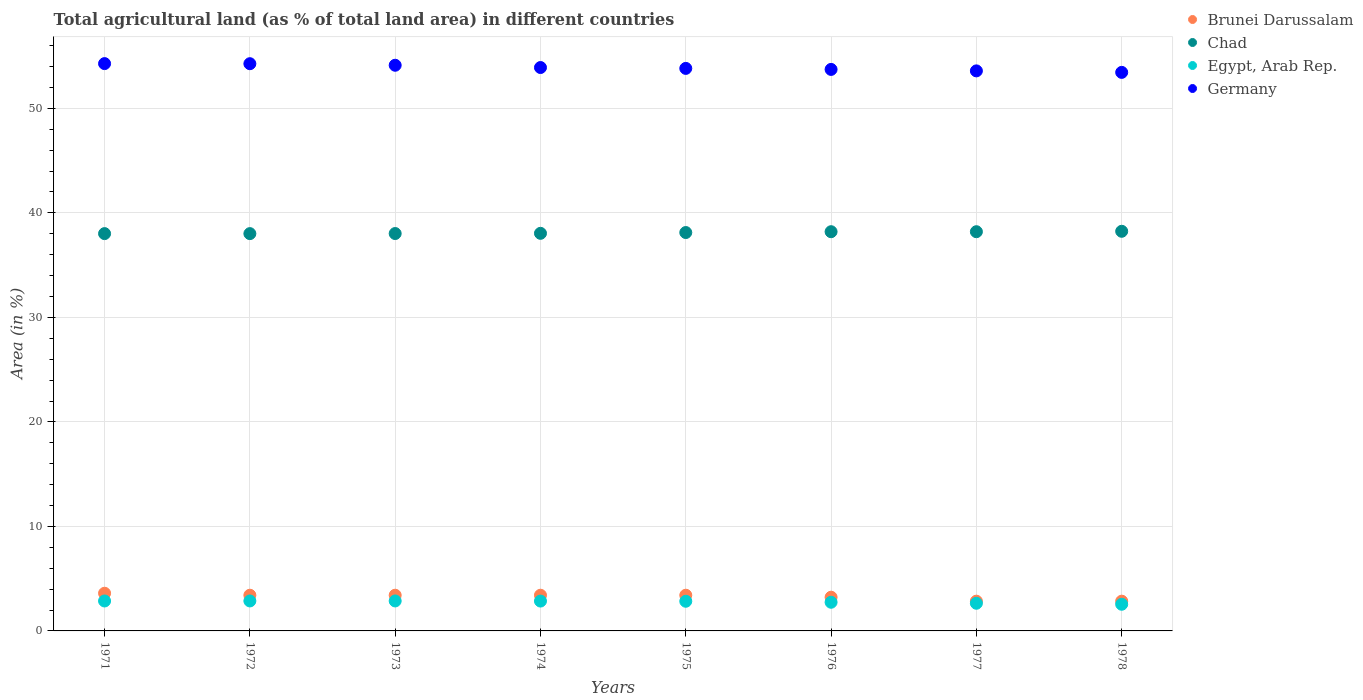What is the percentage of agricultural land in Chad in 1975?
Your answer should be very brief. 38.12. Across all years, what is the maximum percentage of agricultural land in Chad?
Offer a terse response. 38.24. Across all years, what is the minimum percentage of agricultural land in Brunei Darussalam?
Your response must be concise. 2.85. In which year was the percentage of agricultural land in Egypt, Arab Rep. minimum?
Your answer should be very brief. 1978. What is the total percentage of agricultural land in Germany in the graph?
Your response must be concise. 431.18. What is the difference between the percentage of agricultural land in Chad in 1975 and that in 1977?
Provide a succinct answer. -0.08. What is the difference between the percentage of agricultural land in Egypt, Arab Rep. in 1973 and the percentage of agricultural land in Chad in 1974?
Provide a short and direct response. -35.18. What is the average percentage of agricultural land in Egypt, Arab Rep. per year?
Offer a terse response. 2.78. In the year 1978, what is the difference between the percentage of agricultural land in Chad and percentage of agricultural land in Brunei Darussalam?
Offer a very short reply. 35.39. In how many years, is the percentage of agricultural land in Germany greater than 38 %?
Your answer should be very brief. 8. What is the ratio of the percentage of agricultural land in Chad in 1973 to that in 1974?
Your answer should be very brief. 1. Is the difference between the percentage of agricultural land in Chad in 1972 and 1973 greater than the difference between the percentage of agricultural land in Brunei Darussalam in 1972 and 1973?
Your response must be concise. No. What is the difference between the highest and the second highest percentage of agricultural land in Brunei Darussalam?
Your response must be concise. 0.19. What is the difference between the highest and the lowest percentage of agricultural land in Chad?
Make the answer very short. 0.22. In how many years, is the percentage of agricultural land in Germany greater than the average percentage of agricultural land in Germany taken over all years?
Make the answer very short. 4. How many dotlines are there?
Your answer should be very brief. 4. How many years are there in the graph?
Provide a short and direct response. 8. What is the difference between two consecutive major ticks on the Y-axis?
Ensure brevity in your answer.  10. Does the graph contain grids?
Provide a short and direct response. Yes. How many legend labels are there?
Give a very brief answer. 4. How are the legend labels stacked?
Provide a short and direct response. Vertical. What is the title of the graph?
Your answer should be compact. Total agricultural land (as % of total land area) in different countries. What is the label or title of the X-axis?
Keep it short and to the point. Years. What is the label or title of the Y-axis?
Give a very brief answer. Area (in %). What is the Area (in %) of Brunei Darussalam in 1971?
Make the answer very short. 3.61. What is the Area (in %) in Chad in 1971?
Make the answer very short. 38.02. What is the Area (in %) in Egypt, Arab Rep. in 1971?
Your answer should be compact. 2.87. What is the Area (in %) of Germany in 1971?
Your answer should be very brief. 54.28. What is the Area (in %) of Brunei Darussalam in 1972?
Your response must be concise. 3.42. What is the Area (in %) in Chad in 1972?
Make the answer very short. 38.02. What is the Area (in %) in Egypt, Arab Rep. in 1972?
Your answer should be very brief. 2.87. What is the Area (in %) of Germany in 1972?
Offer a terse response. 54.27. What is the Area (in %) of Brunei Darussalam in 1973?
Your answer should be compact. 3.42. What is the Area (in %) of Chad in 1973?
Your answer should be very brief. 38.02. What is the Area (in %) in Egypt, Arab Rep. in 1973?
Give a very brief answer. 2.87. What is the Area (in %) of Germany in 1973?
Your response must be concise. 54.13. What is the Area (in %) of Brunei Darussalam in 1974?
Your answer should be very brief. 3.42. What is the Area (in %) in Chad in 1974?
Your answer should be compact. 38.04. What is the Area (in %) of Egypt, Arab Rep. in 1974?
Your answer should be very brief. 2.86. What is the Area (in %) of Germany in 1974?
Offer a terse response. 53.91. What is the Area (in %) in Brunei Darussalam in 1975?
Provide a short and direct response. 3.42. What is the Area (in %) in Chad in 1975?
Keep it short and to the point. 38.12. What is the Area (in %) in Egypt, Arab Rep. in 1975?
Offer a terse response. 2.84. What is the Area (in %) in Germany in 1975?
Make the answer very short. 53.83. What is the Area (in %) in Brunei Darussalam in 1976?
Your answer should be very brief. 3.23. What is the Area (in %) in Chad in 1976?
Offer a terse response. 38.2. What is the Area (in %) in Egypt, Arab Rep. in 1976?
Provide a succinct answer. 2.74. What is the Area (in %) in Germany in 1976?
Your answer should be compact. 53.73. What is the Area (in %) in Brunei Darussalam in 1977?
Ensure brevity in your answer.  2.85. What is the Area (in %) in Chad in 1977?
Your response must be concise. 38.2. What is the Area (in %) in Egypt, Arab Rep. in 1977?
Offer a terse response. 2.65. What is the Area (in %) of Germany in 1977?
Your answer should be compact. 53.59. What is the Area (in %) of Brunei Darussalam in 1978?
Your answer should be compact. 2.85. What is the Area (in %) in Chad in 1978?
Ensure brevity in your answer.  38.24. What is the Area (in %) in Egypt, Arab Rep. in 1978?
Provide a short and direct response. 2.55. What is the Area (in %) in Germany in 1978?
Provide a short and direct response. 53.44. Across all years, what is the maximum Area (in %) of Brunei Darussalam?
Your answer should be compact. 3.61. Across all years, what is the maximum Area (in %) of Chad?
Offer a very short reply. 38.24. Across all years, what is the maximum Area (in %) of Egypt, Arab Rep.?
Provide a succinct answer. 2.87. Across all years, what is the maximum Area (in %) in Germany?
Offer a terse response. 54.28. Across all years, what is the minimum Area (in %) of Brunei Darussalam?
Offer a very short reply. 2.85. Across all years, what is the minimum Area (in %) in Chad?
Your answer should be compact. 38.02. Across all years, what is the minimum Area (in %) of Egypt, Arab Rep.?
Give a very brief answer. 2.55. Across all years, what is the minimum Area (in %) of Germany?
Offer a terse response. 53.44. What is the total Area (in %) in Brunei Darussalam in the graph?
Your response must be concise. 26.19. What is the total Area (in %) of Chad in the graph?
Ensure brevity in your answer.  304.86. What is the total Area (in %) of Egypt, Arab Rep. in the graph?
Your answer should be very brief. 22.24. What is the total Area (in %) in Germany in the graph?
Make the answer very short. 431.18. What is the difference between the Area (in %) of Brunei Darussalam in 1971 and that in 1972?
Your answer should be very brief. 0.19. What is the difference between the Area (in %) in Chad in 1971 and that in 1972?
Provide a succinct answer. 0. What is the difference between the Area (in %) in Egypt, Arab Rep. in 1971 and that in 1972?
Keep it short and to the point. -0. What is the difference between the Area (in %) of Germany in 1971 and that in 1972?
Offer a very short reply. 0.01. What is the difference between the Area (in %) in Brunei Darussalam in 1971 and that in 1973?
Offer a very short reply. 0.19. What is the difference between the Area (in %) of Chad in 1971 and that in 1973?
Ensure brevity in your answer.  -0.01. What is the difference between the Area (in %) of Egypt, Arab Rep. in 1971 and that in 1973?
Your answer should be compact. -0. What is the difference between the Area (in %) of Germany in 1971 and that in 1973?
Offer a very short reply. 0.16. What is the difference between the Area (in %) of Brunei Darussalam in 1971 and that in 1974?
Your response must be concise. 0.19. What is the difference between the Area (in %) in Chad in 1971 and that in 1974?
Offer a terse response. -0.03. What is the difference between the Area (in %) in Egypt, Arab Rep. in 1971 and that in 1974?
Your answer should be very brief. 0.01. What is the difference between the Area (in %) in Germany in 1971 and that in 1974?
Keep it short and to the point. 0.38. What is the difference between the Area (in %) of Brunei Darussalam in 1971 and that in 1975?
Offer a terse response. 0.19. What is the difference between the Area (in %) in Chad in 1971 and that in 1975?
Your answer should be very brief. -0.1. What is the difference between the Area (in %) in Egypt, Arab Rep. in 1971 and that in 1975?
Ensure brevity in your answer.  0.03. What is the difference between the Area (in %) in Germany in 1971 and that in 1975?
Ensure brevity in your answer.  0.46. What is the difference between the Area (in %) of Brunei Darussalam in 1971 and that in 1976?
Give a very brief answer. 0.38. What is the difference between the Area (in %) in Chad in 1971 and that in 1976?
Provide a short and direct response. -0.18. What is the difference between the Area (in %) of Egypt, Arab Rep. in 1971 and that in 1976?
Keep it short and to the point. 0.12. What is the difference between the Area (in %) of Germany in 1971 and that in 1976?
Offer a terse response. 0.56. What is the difference between the Area (in %) in Brunei Darussalam in 1971 and that in 1977?
Make the answer very short. 0.76. What is the difference between the Area (in %) of Chad in 1971 and that in 1977?
Ensure brevity in your answer.  -0.18. What is the difference between the Area (in %) in Egypt, Arab Rep. in 1971 and that in 1977?
Your response must be concise. 0.22. What is the difference between the Area (in %) of Germany in 1971 and that in 1977?
Make the answer very short. 0.7. What is the difference between the Area (in %) in Brunei Darussalam in 1971 and that in 1978?
Your answer should be very brief. 0.76. What is the difference between the Area (in %) of Chad in 1971 and that in 1978?
Your answer should be very brief. -0.22. What is the difference between the Area (in %) of Egypt, Arab Rep. in 1971 and that in 1978?
Keep it short and to the point. 0.31. What is the difference between the Area (in %) in Germany in 1971 and that in 1978?
Offer a terse response. 0.84. What is the difference between the Area (in %) in Brunei Darussalam in 1972 and that in 1973?
Provide a succinct answer. 0. What is the difference between the Area (in %) in Chad in 1972 and that in 1973?
Offer a terse response. -0.01. What is the difference between the Area (in %) of Egypt, Arab Rep. in 1972 and that in 1973?
Give a very brief answer. 0. What is the difference between the Area (in %) in Germany in 1972 and that in 1973?
Provide a short and direct response. 0.15. What is the difference between the Area (in %) of Chad in 1972 and that in 1974?
Offer a terse response. -0.03. What is the difference between the Area (in %) of Egypt, Arab Rep. in 1972 and that in 1974?
Provide a short and direct response. 0.01. What is the difference between the Area (in %) in Germany in 1972 and that in 1974?
Make the answer very short. 0.37. What is the difference between the Area (in %) of Brunei Darussalam in 1972 and that in 1975?
Your response must be concise. 0. What is the difference between the Area (in %) in Chad in 1972 and that in 1975?
Your answer should be very brief. -0.1. What is the difference between the Area (in %) in Egypt, Arab Rep. in 1972 and that in 1975?
Your answer should be compact. 0.03. What is the difference between the Area (in %) of Germany in 1972 and that in 1975?
Provide a succinct answer. 0.45. What is the difference between the Area (in %) of Brunei Darussalam in 1972 and that in 1976?
Your answer should be compact. 0.19. What is the difference between the Area (in %) of Chad in 1972 and that in 1976?
Make the answer very short. -0.18. What is the difference between the Area (in %) in Egypt, Arab Rep. in 1972 and that in 1976?
Your answer should be very brief. 0.13. What is the difference between the Area (in %) of Germany in 1972 and that in 1976?
Offer a terse response. 0.55. What is the difference between the Area (in %) in Brunei Darussalam in 1972 and that in 1977?
Make the answer very short. 0.57. What is the difference between the Area (in %) of Chad in 1972 and that in 1977?
Provide a short and direct response. -0.18. What is the difference between the Area (in %) in Egypt, Arab Rep. in 1972 and that in 1977?
Offer a very short reply. 0.22. What is the difference between the Area (in %) of Germany in 1972 and that in 1977?
Your answer should be compact. 0.69. What is the difference between the Area (in %) of Brunei Darussalam in 1972 and that in 1978?
Provide a short and direct response. 0.57. What is the difference between the Area (in %) in Chad in 1972 and that in 1978?
Give a very brief answer. -0.22. What is the difference between the Area (in %) in Egypt, Arab Rep. in 1972 and that in 1978?
Provide a short and direct response. 0.32. What is the difference between the Area (in %) of Germany in 1972 and that in 1978?
Offer a terse response. 0.83. What is the difference between the Area (in %) in Brunei Darussalam in 1973 and that in 1974?
Make the answer very short. 0. What is the difference between the Area (in %) in Chad in 1973 and that in 1974?
Your response must be concise. -0.02. What is the difference between the Area (in %) in Egypt, Arab Rep. in 1973 and that in 1974?
Ensure brevity in your answer.  0.01. What is the difference between the Area (in %) in Germany in 1973 and that in 1974?
Offer a very short reply. 0.22. What is the difference between the Area (in %) in Chad in 1973 and that in 1975?
Your answer should be very brief. -0.1. What is the difference between the Area (in %) of Egypt, Arab Rep. in 1973 and that in 1975?
Your answer should be compact. 0.03. What is the difference between the Area (in %) of Germany in 1973 and that in 1975?
Ensure brevity in your answer.  0.3. What is the difference between the Area (in %) of Brunei Darussalam in 1973 and that in 1976?
Keep it short and to the point. 0.19. What is the difference between the Area (in %) of Chad in 1973 and that in 1976?
Give a very brief answer. -0.17. What is the difference between the Area (in %) of Egypt, Arab Rep. in 1973 and that in 1976?
Offer a very short reply. 0.13. What is the difference between the Area (in %) of Germany in 1973 and that in 1976?
Keep it short and to the point. 0.4. What is the difference between the Area (in %) in Brunei Darussalam in 1973 and that in 1977?
Your answer should be compact. 0.57. What is the difference between the Area (in %) in Chad in 1973 and that in 1977?
Offer a very short reply. -0.17. What is the difference between the Area (in %) of Egypt, Arab Rep. in 1973 and that in 1977?
Offer a very short reply. 0.22. What is the difference between the Area (in %) of Germany in 1973 and that in 1977?
Give a very brief answer. 0.54. What is the difference between the Area (in %) of Brunei Darussalam in 1973 and that in 1978?
Your answer should be compact. 0.57. What is the difference between the Area (in %) in Chad in 1973 and that in 1978?
Offer a very short reply. -0.21. What is the difference between the Area (in %) of Egypt, Arab Rep. in 1973 and that in 1978?
Offer a terse response. 0.32. What is the difference between the Area (in %) in Germany in 1973 and that in 1978?
Provide a succinct answer. 0.68. What is the difference between the Area (in %) of Chad in 1974 and that in 1975?
Ensure brevity in your answer.  -0.08. What is the difference between the Area (in %) in Egypt, Arab Rep. in 1974 and that in 1975?
Your answer should be very brief. 0.02. What is the difference between the Area (in %) of Germany in 1974 and that in 1975?
Your answer should be very brief. 0.08. What is the difference between the Area (in %) in Brunei Darussalam in 1974 and that in 1976?
Your answer should be very brief. 0.19. What is the difference between the Area (in %) in Chad in 1974 and that in 1976?
Ensure brevity in your answer.  -0.15. What is the difference between the Area (in %) in Egypt, Arab Rep. in 1974 and that in 1976?
Keep it short and to the point. 0.11. What is the difference between the Area (in %) in Germany in 1974 and that in 1976?
Provide a short and direct response. 0.18. What is the difference between the Area (in %) of Brunei Darussalam in 1974 and that in 1977?
Your answer should be compact. 0.57. What is the difference between the Area (in %) of Chad in 1974 and that in 1977?
Keep it short and to the point. -0.15. What is the difference between the Area (in %) of Egypt, Arab Rep. in 1974 and that in 1977?
Offer a very short reply. 0.21. What is the difference between the Area (in %) of Germany in 1974 and that in 1977?
Offer a terse response. 0.32. What is the difference between the Area (in %) of Brunei Darussalam in 1974 and that in 1978?
Make the answer very short. 0.57. What is the difference between the Area (in %) of Chad in 1974 and that in 1978?
Provide a succinct answer. -0.19. What is the difference between the Area (in %) of Egypt, Arab Rep. in 1974 and that in 1978?
Offer a terse response. 0.3. What is the difference between the Area (in %) of Germany in 1974 and that in 1978?
Provide a short and direct response. 0.46. What is the difference between the Area (in %) of Brunei Darussalam in 1975 and that in 1976?
Make the answer very short. 0.19. What is the difference between the Area (in %) of Chad in 1975 and that in 1976?
Offer a terse response. -0.08. What is the difference between the Area (in %) of Egypt, Arab Rep. in 1975 and that in 1976?
Keep it short and to the point. 0.1. What is the difference between the Area (in %) in Germany in 1975 and that in 1976?
Ensure brevity in your answer.  0.1. What is the difference between the Area (in %) of Brunei Darussalam in 1975 and that in 1977?
Offer a terse response. 0.57. What is the difference between the Area (in %) of Chad in 1975 and that in 1977?
Give a very brief answer. -0.08. What is the difference between the Area (in %) in Egypt, Arab Rep. in 1975 and that in 1977?
Your answer should be very brief. 0.19. What is the difference between the Area (in %) of Germany in 1975 and that in 1977?
Give a very brief answer. 0.24. What is the difference between the Area (in %) of Brunei Darussalam in 1975 and that in 1978?
Make the answer very short. 0.57. What is the difference between the Area (in %) of Chad in 1975 and that in 1978?
Your response must be concise. -0.12. What is the difference between the Area (in %) of Egypt, Arab Rep. in 1975 and that in 1978?
Provide a short and direct response. 0.29. What is the difference between the Area (in %) in Germany in 1975 and that in 1978?
Provide a short and direct response. 0.38. What is the difference between the Area (in %) of Brunei Darussalam in 1976 and that in 1977?
Offer a very short reply. 0.38. What is the difference between the Area (in %) in Chad in 1976 and that in 1977?
Ensure brevity in your answer.  0. What is the difference between the Area (in %) in Egypt, Arab Rep. in 1976 and that in 1977?
Your response must be concise. 0.1. What is the difference between the Area (in %) of Germany in 1976 and that in 1977?
Your answer should be compact. 0.14. What is the difference between the Area (in %) in Brunei Darussalam in 1976 and that in 1978?
Offer a terse response. 0.38. What is the difference between the Area (in %) of Chad in 1976 and that in 1978?
Provide a short and direct response. -0.04. What is the difference between the Area (in %) in Egypt, Arab Rep. in 1976 and that in 1978?
Provide a short and direct response. 0.19. What is the difference between the Area (in %) of Germany in 1976 and that in 1978?
Provide a succinct answer. 0.28. What is the difference between the Area (in %) of Chad in 1977 and that in 1978?
Provide a short and direct response. -0.04. What is the difference between the Area (in %) of Egypt, Arab Rep. in 1977 and that in 1978?
Your response must be concise. 0.1. What is the difference between the Area (in %) in Germany in 1977 and that in 1978?
Give a very brief answer. 0.14. What is the difference between the Area (in %) of Brunei Darussalam in 1971 and the Area (in %) of Chad in 1972?
Provide a short and direct response. -34.41. What is the difference between the Area (in %) in Brunei Darussalam in 1971 and the Area (in %) in Egypt, Arab Rep. in 1972?
Keep it short and to the point. 0.74. What is the difference between the Area (in %) in Brunei Darussalam in 1971 and the Area (in %) in Germany in 1972?
Give a very brief answer. -50.67. What is the difference between the Area (in %) of Chad in 1971 and the Area (in %) of Egypt, Arab Rep. in 1972?
Provide a short and direct response. 35.15. What is the difference between the Area (in %) in Chad in 1971 and the Area (in %) in Germany in 1972?
Give a very brief answer. -16.26. What is the difference between the Area (in %) of Egypt, Arab Rep. in 1971 and the Area (in %) of Germany in 1972?
Ensure brevity in your answer.  -51.41. What is the difference between the Area (in %) of Brunei Darussalam in 1971 and the Area (in %) of Chad in 1973?
Your answer should be compact. -34.42. What is the difference between the Area (in %) of Brunei Darussalam in 1971 and the Area (in %) of Egypt, Arab Rep. in 1973?
Ensure brevity in your answer.  0.74. What is the difference between the Area (in %) of Brunei Darussalam in 1971 and the Area (in %) of Germany in 1973?
Offer a very short reply. -50.52. What is the difference between the Area (in %) in Chad in 1971 and the Area (in %) in Egypt, Arab Rep. in 1973?
Offer a very short reply. 35.15. What is the difference between the Area (in %) in Chad in 1971 and the Area (in %) in Germany in 1973?
Give a very brief answer. -16.11. What is the difference between the Area (in %) of Egypt, Arab Rep. in 1971 and the Area (in %) of Germany in 1973?
Offer a very short reply. -51.26. What is the difference between the Area (in %) in Brunei Darussalam in 1971 and the Area (in %) in Chad in 1974?
Your answer should be compact. -34.44. What is the difference between the Area (in %) of Brunei Darussalam in 1971 and the Area (in %) of Egypt, Arab Rep. in 1974?
Make the answer very short. 0.75. What is the difference between the Area (in %) of Brunei Darussalam in 1971 and the Area (in %) of Germany in 1974?
Ensure brevity in your answer.  -50.3. What is the difference between the Area (in %) of Chad in 1971 and the Area (in %) of Egypt, Arab Rep. in 1974?
Ensure brevity in your answer.  35.16. What is the difference between the Area (in %) of Chad in 1971 and the Area (in %) of Germany in 1974?
Offer a terse response. -15.89. What is the difference between the Area (in %) in Egypt, Arab Rep. in 1971 and the Area (in %) in Germany in 1974?
Provide a short and direct response. -51.04. What is the difference between the Area (in %) in Brunei Darussalam in 1971 and the Area (in %) in Chad in 1975?
Provide a succinct answer. -34.51. What is the difference between the Area (in %) of Brunei Darussalam in 1971 and the Area (in %) of Egypt, Arab Rep. in 1975?
Give a very brief answer. 0.77. What is the difference between the Area (in %) in Brunei Darussalam in 1971 and the Area (in %) in Germany in 1975?
Offer a very short reply. -50.22. What is the difference between the Area (in %) of Chad in 1971 and the Area (in %) of Egypt, Arab Rep. in 1975?
Keep it short and to the point. 35.18. What is the difference between the Area (in %) of Chad in 1971 and the Area (in %) of Germany in 1975?
Keep it short and to the point. -15.81. What is the difference between the Area (in %) of Egypt, Arab Rep. in 1971 and the Area (in %) of Germany in 1975?
Offer a terse response. -50.96. What is the difference between the Area (in %) of Brunei Darussalam in 1971 and the Area (in %) of Chad in 1976?
Make the answer very short. -34.59. What is the difference between the Area (in %) of Brunei Darussalam in 1971 and the Area (in %) of Egypt, Arab Rep. in 1976?
Give a very brief answer. 0.86. What is the difference between the Area (in %) of Brunei Darussalam in 1971 and the Area (in %) of Germany in 1976?
Your answer should be very brief. -50.12. What is the difference between the Area (in %) of Chad in 1971 and the Area (in %) of Egypt, Arab Rep. in 1976?
Your answer should be compact. 35.27. What is the difference between the Area (in %) in Chad in 1971 and the Area (in %) in Germany in 1976?
Ensure brevity in your answer.  -15.71. What is the difference between the Area (in %) in Egypt, Arab Rep. in 1971 and the Area (in %) in Germany in 1976?
Make the answer very short. -50.86. What is the difference between the Area (in %) of Brunei Darussalam in 1971 and the Area (in %) of Chad in 1977?
Ensure brevity in your answer.  -34.59. What is the difference between the Area (in %) of Brunei Darussalam in 1971 and the Area (in %) of Egypt, Arab Rep. in 1977?
Give a very brief answer. 0.96. What is the difference between the Area (in %) in Brunei Darussalam in 1971 and the Area (in %) in Germany in 1977?
Your answer should be compact. -49.98. What is the difference between the Area (in %) in Chad in 1971 and the Area (in %) in Egypt, Arab Rep. in 1977?
Keep it short and to the point. 35.37. What is the difference between the Area (in %) in Chad in 1971 and the Area (in %) in Germany in 1977?
Make the answer very short. -15.57. What is the difference between the Area (in %) of Egypt, Arab Rep. in 1971 and the Area (in %) of Germany in 1977?
Ensure brevity in your answer.  -50.72. What is the difference between the Area (in %) in Brunei Darussalam in 1971 and the Area (in %) in Chad in 1978?
Give a very brief answer. -34.63. What is the difference between the Area (in %) in Brunei Darussalam in 1971 and the Area (in %) in Egypt, Arab Rep. in 1978?
Provide a short and direct response. 1.05. What is the difference between the Area (in %) in Brunei Darussalam in 1971 and the Area (in %) in Germany in 1978?
Offer a terse response. -49.84. What is the difference between the Area (in %) in Chad in 1971 and the Area (in %) in Egypt, Arab Rep. in 1978?
Keep it short and to the point. 35.46. What is the difference between the Area (in %) in Chad in 1971 and the Area (in %) in Germany in 1978?
Your response must be concise. -15.43. What is the difference between the Area (in %) of Egypt, Arab Rep. in 1971 and the Area (in %) of Germany in 1978?
Provide a short and direct response. -50.58. What is the difference between the Area (in %) of Brunei Darussalam in 1972 and the Area (in %) of Chad in 1973?
Make the answer very short. -34.61. What is the difference between the Area (in %) of Brunei Darussalam in 1972 and the Area (in %) of Egypt, Arab Rep. in 1973?
Make the answer very short. 0.55. What is the difference between the Area (in %) in Brunei Darussalam in 1972 and the Area (in %) in Germany in 1973?
Keep it short and to the point. -50.71. What is the difference between the Area (in %) in Chad in 1972 and the Area (in %) in Egypt, Arab Rep. in 1973?
Provide a succinct answer. 35.15. What is the difference between the Area (in %) in Chad in 1972 and the Area (in %) in Germany in 1973?
Provide a succinct answer. -16.11. What is the difference between the Area (in %) in Egypt, Arab Rep. in 1972 and the Area (in %) in Germany in 1973?
Make the answer very short. -51.26. What is the difference between the Area (in %) of Brunei Darussalam in 1972 and the Area (in %) of Chad in 1974?
Ensure brevity in your answer.  -34.63. What is the difference between the Area (in %) in Brunei Darussalam in 1972 and the Area (in %) in Egypt, Arab Rep. in 1974?
Give a very brief answer. 0.56. What is the difference between the Area (in %) in Brunei Darussalam in 1972 and the Area (in %) in Germany in 1974?
Offer a very short reply. -50.49. What is the difference between the Area (in %) in Chad in 1972 and the Area (in %) in Egypt, Arab Rep. in 1974?
Offer a very short reply. 35.16. What is the difference between the Area (in %) in Chad in 1972 and the Area (in %) in Germany in 1974?
Your answer should be compact. -15.89. What is the difference between the Area (in %) in Egypt, Arab Rep. in 1972 and the Area (in %) in Germany in 1974?
Your response must be concise. -51.04. What is the difference between the Area (in %) of Brunei Darussalam in 1972 and the Area (in %) of Chad in 1975?
Make the answer very short. -34.7. What is the difference between the Area (in %) in Brunei Darussalam in 1972 and the Area (in %) in Egypt, Arab Rep. in 1975?
Ensure brevity in your answer.  0.58. What is the difference between the Area (in %) in Brunei Darussalam in 1972 and the Area (in %) in Germany in 1975?
Offer a very short reply. -50.41. What is the difference between the Area (in %) in Chad in 1972 and the Area (in %) in Egypt, Arab Rep. in 1975?
Give a very brief answer. 35.18. What is the difference between the Area (in %) in Chad in 1972 and the Area (in %) in Germany in 1975?
Your answer should be very brief. -15.81. What is the difference between the Area (in %) of Egypt, Arab Rep. in 1972 and the Area (in %) of Germany in 1975?
Keep it short and to the point. -50.96. What is the difference between the Area (in %) in Brunei Darussalam in 1972 and the Area (in %) in Chad in 1976?
Make the answer very short. -34.78. What is the difference between the Area (in %) of Brunei Darussalam in 1972 and the Area (in %) of Egypt, Arab Rep. in 1976?
Your answer should be compact. 0.67. What is the difference between the Area (in %) in Brunei Darussalam in 1972 and the Area (in %) in Germany in 1976?
Ensure brevity in your answer.  -50.31. What is the difference between the Area (in %) of Chad in 1972 and the Area (in %) of Egypt, Arab Rep. in 1976?
Provide a succinct answer. 35.27. What is the difference between the Area (in %) in Chad in 1972 and the Area (in %) in Germany in 1976?
Provide a succinct answer. -15.71. What is the difference between the Area (in %) in Egypt, Arab Rep. in 1972 and the Area (in %) in Germany in 1976?
Offer a terse response. -50.86. What is the difference between the Area (in %) of Brunei Darussalam in 1972 and the Area (in %) of Chad in 1977?
Your answer should be very brief. -34.78. What is the difference between the Area (in %) of Brunei Darussalam in 1972 and the Area (in %) of Egypt, Arab Rep. in 1977?
Provide a succinct answer. 0.77. What is the difference between the Area (in %) in Brunei Darussalam in 1972 and the Area (in %) in Germany in 1977?
Your answer should be compact. -50.17. What is the difference between the Area (in %) of Chad in 1972 and the Area (in %) of Egypt, Arab Rep. in 1977?
Make the answer very short. 35.37. What is the difference between the Area (in %) in Chad in 1972 and the Area (in %) in Germany in 1977?
Your answer should be very brief. -15.57. What is the difference between the Area (in %) in Egypt, Arab Rep. in 1972 and the Area (in %) in Germany in 1977?
Your response must be concise. -50.72. What is the difference between the Area (in %) in Brunei Darussalam in 1972 and the Area (in %) in Chad in 1978?
Your answer should be compact. -34.82. What is the difference between the Area (in %) of Brunei Darussalam in 1972 and the Area (in %) of Egypt, Arab Rep. in 1978?
Offer a very short reply. 0.86. What is the difference between the Area (in %) in Brunei Darussalam in 1972 and the Area (in %) in Germany in 1978?
Provide a succinct answer. -50.03. What is the difference between the Area (in %) in Chad in 1972 and the Area (in %) in Egypt, Arab Rep. in 1978?
Offer a terse response. 35.46. What is the difference between the Area (in %) of Chad in 1972 and the Area (in %) of Germany in 1978?
Your response must be concise. -15.43. What is the difference between the Area (in %) in Egypt, Arab Rep. in 1972 and the Area (in %) in Germany in 1978?
Offer a terse response. -50.58. What is the difference between the Area (in %) of Brunei Darussalam in 1973 and the Area (in %) of Chad in 1974?
Make the answer very short. -34.63. What is the difference between the Area (in %) in Brunei Darussalam in 1973 and the Area (in %) in Egypt, Arab Rep. in 1974?
Provide a succinct answer. 0.56. What is the difference between the Area (in %) of Brunei Darussalam in 1973 and the Area (in %) of Germany in 1974?
Your answer should be compact. -50.49. What is the difference between the Area (in %) in Chad in 1973 and the Area (in %) in Egypt, Arab Rep. in 1974?
Provide a succinct answer. 35.17. What is the difference between the Area (in %) of Chad in 1973 and the Area (in %) of Germany in 1974?
Provide a short and direct response. -15.88. What is the difference between the Area (in %) in Egypt, Arab Rep. in 1973 and the Area (in %) in Germany in 1974?
Your answer should be very brief. -51.04. What is the difference between the Area (in %) of Brunei Darussalam in 1973 and the Area (in %) of Chad in 1975?
Offer a terse response. -34.7. What is the difference between the Area (in %) of Brunei Darussalam in 1973 and the Area (in %) of Egypt, Arab Rep. in 1975?
Give a very brief answer. 0.58. What is the difference between the Area (in %) in Brunei Darussalam in 1973 and the Area (in %) in Germany in 1975?
Provide a short and direct response. -50.41. What is the difference between the Area (in %) in Chad in 1973 and the Area (in %) in Egypt, Arab Rep. in 1975?
Your response must be concise. 35.19. What is the difference between the Area (in %) of Chad in 1973 and the Area (in %) of Germany in 1975?
Your response must be concise. -15.8. What is the difference between the Area (in %) in Egypt, Arab Rep. in 1973 and the Area (in %) in Germany in 1975?
Provide a succinct answer. -50.96. What is the difference between the Area (in %) in Brunei Darussalam in 1973 and the Area (in %) in Chad in 1976?
Keep it short and to the point. -34.78. What is the difference between the Area (in %) of Brunei Darussalam in 1973 and the Area (in %) of Egypt, Arab Rep. in 1976?
Give a very brief answer. 0.67. What is the difference between the Area (in %) of Brunei Darussalam in 1973 and the Area (in %) of Germany in 1976?
Ensure brevity in your answer.  -50.31. What is the difference between the Area (in %) of Chad in 1973 and the Area (in %) of Egypt, Arab Rep. in 1976?
Your response must be concise. 35.28. What is the difference between the Area (in %) in Chad in 1973 and the Area (in %) in Germany in 1976?
Keep it short and to the point. -15.7. What is the difference between the Area (in %) of Egypt, Arab Rep. in 1973 and the Area (in %) of Germany in 1976?
Provide a short and direct response. -50.86. What is the difference between the Area (in %) in Brunei Darussalam in 1973 and the Area (in %) in Chad in 1977?
Your answer should be very brief. -34.78. What is the difference between the Area (in %) in Brunei Darussalam in 1973 and the Area (in %) in Egypt, Arab Rep. in 1977?
Make the answer very short. 0.77. What is the difference between the Area (in %) of Brunei Darussalam in 1973 and the Area (in %) of Germany in 1977?
Give a very brief answer. -50.17. What is the difference between the Area (in %) in Chad in 1973 and the Area (in %) in Egypt, Arab Rep. in 1977?
Give a very brief answer. 35.38. What is the difference between the Area (in %) in Chad in 1973 and the Area (in %) in Germany in 1977?
Your answer should be compact. -15.56. What is the difference between the Area (in %) of Egypt, Arab Rep. in 1973 and the Area (in %) of Germany in 1977?
Provide a succinct answer. -50.72. What is the difference between the Area (in %) of Brunei Darussalam in 1973 and the Area (in %) of Chad in 1978?
Give a very brief answer. -34.82. What is the difference between the Area (in %) in Brunei Darussalam in 1973 and the Area (in %) in Egypt, Arab Rep. in 1978?
Your answer should be compact. 0.86. What is the difference between the Area (in %) of Brunei Darussalam in 1973 and the Area (in %) of Germany in 1978?
Your response must be concise. -50.03. What is the difference between the Area (in %) of Chad in 1973 and the Area (in %) of Egypt, Arab Rep. in 1978?
Offer a terse response. 35.47. What is the difference between the Area (in %) in Chad in 1973 and the Area (in %) in Germany in 1978?
Your answer should be compact. -15.42. What is the difference between the Area (in %) in Egypt, Arab Rep. in 1973 and the Area (in %) in Germany in 1978?
Your answer should be very brief. -50.58. What is the difference between the Area (in %) of Brunei Darussalam in 1974 and the Area (in %) of Chad in 1975?
Ensure brevity in your answer.  -34.7. What is the difference between the Area (in %) in Brunei Darussalam in 1974 and the Area (in %) in Egypt, Arab Rep. in 1975?
Make the answer very short. 0.58. What is the difference between the Area (in %) in Brunei Darussalam in 1974 and the Area (in %) in Germany in 1975?
Your answer should be very brief. -50.41. What is the difference between the Area (in %) of Chad in 1974 and the Area (in %) of Egypt, Arab Rep. in 1975?
Ensure brevity in your answer.  35.21. What is the difference between the Area (in %) in Chad in 1974 and the Area (in %) in Germany in 1975?
Your response must be concise. -15.78. What is the difference between the Area (in %) in Egypt, Arab Rep. in 1974 and the Area (in %) in Germany in 1975?
Give a very brief answer. -50.97. What is the difference between the Area (in %) in Brunei Darussalam in 1974 and the Area (in %) in Chad in 1976?
Provide a succinct answer. -34.78. What is the difference between the Area (in %) of Brunei Darussalam in 1974 and the Area (in %) of Egypt, Arab Rep. in 1976?
Offer a very short reply. 0.67. What is the difference between the Area (in %) in Brunei Darussalam in 1974 and the Area (in %) in Germany in 1976?
Provide a short and direct response. -50.31. What is the difference between the Area (in %) in Chad in 1974 and the Area (in %) in Egypt, Arab Rep. in 1976?
Make the answer very short. 35.3. What is the difference between the Area (in %) of Chad in 1974 and the Area (in %) of Germany in 1976?
Provide a short and direct response. -15.68. What is the difference between the Area (in %) in Egypt, Arab Rep. in 1974 and the Area (in %) in Germany in 1976?
Your answer should be compact. -50.87. What is the difference between the Area (in %) of Brunei Darussalam in 1974 and the Area (in %) of Chad in 1977?
Your answer should be very brief. -34.78. What is the difference between the Area (in %) in Brunei Darussalam in 1974 and the Area (in %) in Egypt, Arab Rep. in 1977?
Make the answer very short. 0.77. What is the difference between the Area (in %) in Brunei Darussalam in 1974 and the Area (in %) in Germany in 1977?
Provide a short and direct response. -50.17. What is the difference between the Area (in %) in Chad in 1974 and the Area (in %) in Egypt, Arab Rep. in 1977?
Make the answer very short. 35.4. What is the difference between the Area (in %) in Chad in 1974 and the Area (in %) in Germany in 1977?
Give a very brief answer. -15.54. What is the difference between the Area (in %) in Egypt, Arab Rep. in 1974 and the Area (in %) in Germany in 1977?
Your answer should be compact. -50.73. What is the difference between the Area (in %) of Brunei Darussalam in 1974 and the Area (in %) of Chad in 1978?
Your response must be concise. -34.82. What is the difference between the Area (in %) of Brunei Darussalam in 1974 and the Area (in %) of Egypt, Arab Rep. in 1978?
Ensure brevity in your answer.  0.86. What is the difference between the Area (in %) in Brunei Darussalam in 1974 and the Area (in %) in Germany in 1978?
Ensure brevity in your answer.  -50.03. What is the difference between the Area (in %) of Chad in 1974 and the Area (in %) of Egypt, Arab Rep. in 1978?
Provide a short and direct response. 35.49. What is the difference between the Area (in %) in Chad in 1974 and the Area (in %) in Germany in 1978?
Your answer should be compact. -15.4. What is the difference between the Area (in %) of Egypt, Arab Rep. in 1974 and the Area (in %) of Germany in 1978?
Offer a very short reply. -50.59. What is the difference between the Area (in %) in Brunei Darussalam in 1975 and the Area (in %) in Chad in 1976?
Give a very brief answer. -34.78. What is the difference between the Area (in %) of Brunei Darussalam in 1975 and the Area (in %) of Egypt, Arab Rep. in 1976?
Keep it short and to the point. 0.67. What is the difference between the Area (in %) of Brunei Darussalam in 1975 and the Area (in %) of Germany in 1976?
Ensure brevity in your answer.  -50.31. What is the difference between the Area (in %) in Chad in 1975 and the Area (in %) in Egypt, Arab Rep. in 1976?
Provide a short and direct response. 35.38. What is the difference between the Area (in %) in Chad in 1975 and the Area (in %) in Germany in 1976?
Provide a short and direct response. -15.61. What is the difference between the Area (in %) in Egypt, Arab Rep. in 1975 and the Area (in %) in Germany in 1976?
Provide a short and direct response. -50.89. What is the difference between the Area (in %) of Brunei Darussalam in 1975 and the Area (in %) of Chad in 1977?
Provide a short and direct response. -34.78. What is the difference between the Area (in %) of Brunei Darussalam in 1975 and the Area (in %) of Egypt, Arab Rep. in 1977?
Your answer should be very brief. 0.77. What is the difference between the Area (in %) of Brunei Darussalam in 1975 and the Area (in %) of Germany in 1977?
Give a very brief answer. -50.17. What is the difference between the Area (in %) in Chad in 1975 and the Area (in %) in Egypt, Arab Rep. in 1977?
Your answer should be very brief. 35.47. What is the difference between the Area (in %) of Chad in 1975 and the Area (in %) of Germany in 1977?
Make the answer very short. -15.47. What is the difference between the Area (in %) of Egypt, Arab Rep. in 1975 and the Area (in %) of Germany in 1977?
Make the answer very short. -50.75. What is the difference between the Area (in %) in Brunei Darussalam in 1975 and the Area (in %) in Chad in 1978?
Keep it short and to the point. -34.82. What is the difference between the Area (in %) of Brunei Darussalam in 1975 and the Area (in %) of Egypt, Arab Rep. in 1978?
Your answer should be very brief. 0.86. What is the difference between the Area (in %) in Brunei Darussalam in 1975 and the Area (in %) in Germany in 1978?
Your answer should be very brief. -50.03. What is the difference between the Area (in %) in Chad in 1975 and the Area (in %) in Egypt, Arab Rep. in 1978?
Provide a succinct answer. 35.57. What is the difference between the Area (in %) of Chad in 1975 and the Area (in %) of Germany in 1978?
Make the answer very short. -15.32. What is the difference between the Area (in %) in Egypt, Arab Rep. in 1975 and the Area (in %) in Germany in 1978?
Make the answer very short. -50.61. What is the difference between the Area (in %) in Brunei Darussalam in 1976 and the Area (in %) in Chad in 1977?
Provide a short and direct response. -34.97. What is the difference between the Area (in %) of Brunei Darussalam in 1976 and the Area (in %) of Egypt, Arab Rep. in 1977?
Make the answer very short. 0.58. What is the difference between the Area (in %) in Brunei Darussalam in 1976 and the Area (in %) in Germany in 1977?
Give a very brief answer. -50.36. What is the difference between the Area (in %) of Chad in 1976 and the Area (in %) of Egypt, Arab Rep. in 1977?
Provide a short and direct response. 35.55. What is the difference between the Area (in %) of Chad in 1976 and the Area (in %) of Germany in 1977?
Provide a succinct answer. -15.39. What is the difference between the Area (in %) in Egypt, Arab Rep. in 1976 and the Area (in %) in Germany in 1977?
Give a very brief answer. -50.84. What is the difference between the Area (in %) of Brunei Darussalam in 1976 and the Area (in %) of Chad in 1978?
Your answer should be compact. -35.01. What is the difference between the Area (in %) in Brunei Darussalam in 1976 and the Area (in %) in Egypt, Arab Rep. in 1978?
Make the answer very short. 0.67. What is the difference between the Area (in %) of Brunei Darussalam in 1976 and the Area (in %) of Germany in 1978?
Provide a short and direct response. -50.22. What is the difference between the Area (in %) of Chad in 1976 and the Area (in %) of Egypt, Arab Rep. in 1978?
Provide a succinct answer. 35.65. What is the difference between the Area (in %) in Chad in 1976 and the Area (in %) in Germany in 1978?
Give a very brief answer. -15.25. What is the difference between the Area (in %) of Egypt, Arab Rep. in 1976 and the Area (in %) of Germany in 1978?
Provide a succinct answer. -50.7. What is the difference between the Area (in %) in Brunei Darussalam in 1977 and the Area (in %) in Chad in 1978?
Provide a short and direct response. -35.39. What is the difference between the Area (in %) in Brunei Darussalam in 1977 and the Area (in %) in Egypt, Arab Rep. in 1978?
Your answer should be very brief. 0.29. What is the difference between the Area (in %) in Brunei Darussalam in 1977 and the Area (in %) in Germany in 1978?
Provide a short and direct response. -50.6. What is the difference between the Area (in %) of Chad in 1977 and the Area (in %) of Egypt, Arab Rep. in 1978?
Give a very brief answer. 35.65. What is the difference between the Area (in %) of Chad in 1977 and the Area (in %) of Germany in 1978?
Offer a very short reply. -15.25. What is the difference between the Area (in %) in Egypt, Arab Rep. in 1977 and the Area (in %) in Germany in 1978?
Make the answer very short. -50.8. What is the average Area (in %) in Brunei Darussalam per year?
Give a very brief answer. 3.27. What is the average Area (in %) of Chad per year?
Ensure brevity in your answer.  38.11. What is the average Area (in %) of Egypt, Arab Rep. per year?
Keep it short and to the point. 2.78. What is the average Area (in %) in Germany per year?
Your response must be concise. 53.9. In the year 1971, what is the difference between the Area (in %) of Brunei Darussalam and Area (in %) of Chad?
Ensure brevity in your answer.  -34.41. In the year 1971, what is the difference between the Area (in %) in Brunei Darussalam and Area (in %) in Egypt, Arab Rep.?
Your answer should be very brief. 0.74. In the year 1971, what is the difference between the Area (in %) of Brunei Darussalam and Area (in %) of Germany?
Your response must be concise. -50.68. In the year 1971, what is the difference between the Area (in %) in Chad and Area (in %) in Egypt, Arab Rep.?
Provide a succinct answer. 35.15. In the year 1971, what is the difference between the Area (in %) in Chad and Area (in %) in Germany?
Your response must be concise. -16.27. In the year 1971, what is the difference between the Area (in %) of Egypt, Arab Rep. and Area (in %) of Germany?
Offer a terse response. -51.42. In the year 1972, what is the difference between the Area (in %) of Brunei Darussalam and Area (in %) of Chad?
Provide a succinct answer. -34.6. In the year 1972, what is the difference between the Area (in %) in Brunei Darussalam and Area (in %) in Egypt, Arab Rep.?
Provide a short and direct response. 0.55. In the year 1972, what is the difference between the Area (in %) of Brunei Darussalam and Area (in %) of Germany?
Provide a succinct answer. -50.86. In the year 1972, what is the difference between the Area (in %) of Chad and Area (in %) of Egypt, Arab Rep.?
Provide a short and direct response. 35.15. In the year 1972, what is the difference between the Area (in %) of Chad and Area (in %) of Germany?
Offer a very short reply. -16.26. In the year 1972, what is the difference between the Area (in %) in Egypt, Arab Rep. and Area (in %) in Germany?
Give a very brief answer. -51.41. In the year 1973, what is the difference between the Area (in %) of Brunei Darussalam and Area (in %) of Chad?
Offer a very short reply. -34.61. In the year 1973, what is the difference between the Area (in %) in Brunei Darussalam and Area (in %) in Egypt, Arab Rep.?
Your answer should be compact. 0.55. In the year 1973, what is the difference between the Area (in %) of Brunei Darussalam and Area (in %) of Germany?
Give a very brief answer. -50.71. In the year 1973, what is the difference between the Area (in %) in Chad and Area (in %) in Egypt, Arab Rep.?
Keep it short and to the point. 35.16. In the year 1973, what is the difference between the Area (in %) of Chad and Area (in %) of Germany?
Offer a very short reply. -16.1. In the year 1973, what is the difference between the Area (in %) in Egypt, Arab Rep. and Area (in %) in Germany?
Offer a terse response. -51.26. In the year 1974, what is the difference between the Area (in %) of Brunei Darussalam and Area (in %) of Chad?
Your response must be concise. -34.63. In the year 1974, what is the difference between the Area (in %) of Brunei Darussalam and Area (in %) of Egypt, Arab Rep.?
Provide a short and direct response. 0.56. In the year 1974, what is the difference between the Area (in %) of Brunei Darussalam and Area (in %) of Germany?
Make the answer very short. -50.49. In the year 1974, what is the difference between the Area (in %) in Chad and Area (in %) in Egypt, Arab Rep.?
Provide a short and direct response. 35.19. In the year 1974, what is the difference between the Area (in %) in Chad and Area (in %) in Germany?
Offer a very short reply. -15.86. In the year 1974, what is the difference between the Area (in %) in Egypt, Arab Rep. and Area (in %) in Germany?
Offer a very short reply. -51.05. In the year 1975, what is the difference between the Area (in %) of Brunei Darussalam and Area (in %) of Chad?
Offer a terse response. -34.7. In the year 1975, what is the difference between the Area (in %) in Brunei Darussalam and Area (in %) in Egypt, Arab Rep.?
Your answer should be compact. 0.58. In the year 1975, what is the difference between the Area (in %) in Brunei Darussalam and Area (in %) in Germany?
Keep it short and to the point. -50.41. In the year 1975, what is the difference between the Area (in %) of Chad and Area (in %) of Egypt, Arab Rep.?
Offer a terse response. 35.28. In the year 1975, what is the difference between the Area (in %) of Chad and Area (in %) of Germany?
Your answer should be very brief. -15.71. In the year 1975, what is the difference between the Area (in %) in Egypt, Arab Rep. and Area (in %) in Germany?
Ensure brevity in your answer.  -50.99. In the year 1976, what is the difference between the Area (in %) of Brunei Darussalam and Area (in %) of Chad?
Keep it short and to the point. -34.97. In the year 1976, what is the difference between the Area (in %) in Brunei Darussalam and Area (in %) in Egypt, Arab Rep.?
Your answer should be very brief. 0.48. In the year 1976, what is the difference between the Area (in %) in Brunei Darussalam and Area (in %) in Germany?
Offer a very short reply. -50.5. In the year 1976, what is the difference between the Area (in %) in Chad and Area (in %) in Egypt, Arab Rep.?
Offer a very short reply. 35.46. In the year 1976, what is the difference between the Area (in %) in Chad and Area (in %) in Germany?
Make the answer very short. -15.53. In the year 1976, what is the difference between the Area (in %) in Egypt, Arab Rep. and Area (in %) in Germany?
Provide a short and direct response. -50.99. In the year 1977, what is the difference between the Area (in %) of Brunei Darussalam and Area (in %) of Chad?
Ensure brevity in your answer.  -35.35. In the year 1977, what is the difference between the Area (in %) in Brunei Darussalam and Area (in %) in Egypt, Arab Rep.?
Your answer should be compact. 0.2. In the year 1977, what is the difference between the Area (in %) of Brunei Darussalam and Area (in %) of Germany?
Provide a succinct answer. -50.74. In the year 1977, what is the difference between the Area (in %) of Chad and Area (in %) of Egypt, Arab Rep.?
Your response must be concise. 35.55. In the year 1977, what is the difference between the Area (in %) in Chad and Area (in %) in Germany?
Your answer should be compact. -15.39. In the year 1977, what is the difference between the Area (in %) in Egypt, Arab Rep. and Area (in %) in Germany?
Provide a succinct answer. -50.94. In the year 1978, what is the difference between the Area (in %) of Brunei Darussalam and Area (in %) of Chad?
Ensure brevity in your answer.  -35.39. In the year 1978, what is the difference between the Area (in %) of Brunei Darussalam and Area (in %) of Egypt, Arab Rep.?
Ensure brevity in your answer.  0.29. In the year 1978, what is the difference between the Area (in %) of Brunei Darussalam and Area (in %) of Germany?
Your answer should be compact. -50.6. In the year 1978, what is the difference between the Area (in %) in Chad and Area (in %) in Egypt, Arab Rep.?
Your answer should be very brief. 35.69. In the year 1978, what is the difference between the Area (in %) of Chad and Area (in %) of Germany?
Make the answer very short. -15.21. In the year 1978, what is the difference between the Area (in %) of Egypt, Arab Rep. and Area (in %) of Germany?
Make the answer very short. -50.89. What is the ratio of the Area (in %) of Brunei Darussalam in 1971 to that in 1972?
Your answer should be very brief. 1.06. What is the ratio of the Area (in %) of Egypt, Arab Rep. in 1971 to that in 1972?
Make the answer very short. 1. What is the ratio of the Area (in %) of Brunei Darussalam in 1971 to that in 1973?
Offer a very short reply. 1.06. What is the ratio of the Area (in %) in Egypt, Arab Rep. in 1971 to that in 1973?
Ensure brevity in your answer.  1. What is the ratio of the Area (in %) in Brunei Darussalam in 1971 to that in 1974?
Provide a succinct answer. 1.06. What is the ratio of the Area (in %) in Chad in 1971 to that in 1974?
Offer a terse response. 1. What is the ratio of the Area (in %) in Brunei Darussalam in 1971 to that in 1975?
Your answer should be compact. 1.06. What is the ratio of the Area (in %) of Chad in 1971 to that in 1975?
Your answer should be compact. 1. What is the ratio of the Area (in %) in Egypt, Arab Rep. in 1971 to that in 1975?
Your response must be concise. 1.01. What is the ratio of the Area (in %) in Germany in 1971 to that in 1975?
Give a very brief answer. 1.01. What is the ratio of the Area (in %) in Brunei Darussalam in 1971 to that in 1976?
Keep it short and to the point. 1.12. What is the ratio of the Area (in %) in Egypt, Arab Rep. in 1971 to that in 1976?
Ensure brevity in your answer.  1.04. What is the ratio of the Area (in %) in Germany in 1971 to that in 1976?
Provide a short and direct response. 1.01. What is the ratio of the Area (in %) of Brunei Darussalam in 1971 to that in 1977?
Offer a very short reply. 1.27. What is the ratio of the Area (in %) of Chad in 1971 to that in 1977?
Provide a succinct answer. 1. What is the ratio of the Area (in %) of Egypt, Arab Rep. in 1971 to that in 1977?
Offer a very short reply. 1.08. What is the ratio of the Area (in %) of Germany in 1971 to that in 1977?
Give a very brief answer. 1.01. What is the ratio of the Area (in %) of Brunei Darussalam in 1971 to that in 1978?
Your answer should be very brief. 1.27. What is the ratio of the Area (in %) in Chad in 1971 to that in 1978?
Your response must be concise. 0.99. What is the ratio of the Area (in %) of Egypt, Arab Rep. in 1971 to that in 1978?
Provide a succinct answer. 1.12. What is the ratio of the Area (in %) of Germany in 1971 to that in 1978?
Ensure brevity in your answer.  1.02. What is the ratio of the Area (in %) of Brunei Darussalam in 1972 to that in 1973?
Give a very brief answer. 1. What is the ratio of the Area (in %) of Egypt, Arab Rep. in 1972 to that in 1973?
Your answer should be compact. 1. What is the ratio of the Area (in %) in Germany in 1972 to that in 1973?
Your answer should be compact. 1. What is the ratio of the Area (in %) of Brunei Darussalam in 1972 to that in 1974?
Offer a very short reply. 1. What is the ratio of the Area (in %) of Egypt, Arab Rep. in 1972 to that in 1974?
Your response must be concise. 1. What is the ratio of the Area (in %) of Germany in 1972 to that in 1974?
Provide a short and direct response. 1.01. What is the ratio of the Area (in %) in Egypt, Arab Rep. in 1972 to that in 1975?
Offer a terse response. 1.01. What is the ratio of the Area (in %) in Germany in 1972 to that in 1975?
Offer a terse response. 1.01. What is the ratio of the Area (in %) of Brunei Darussalam in 1972 to that in 1976?
Ensure brevity in your answer.  1.06. What is the ratio of the Area (in %) in Chad in 1972 to that in 1976?
Your answer should be very brief. 1. What is the ratio of the Area (in %) in Egypt, Arab Rep. in 1972 to that in 1976?
Provide a succinct answer. 1.05. What is the ratio of the Area (in %) in Germany in 1972 to that in 1976?
Offer a terse response. 1.01. What is the ratio of the Area (in %) of Egypt, Arab Rep. in 1972 to that in 1977?
Offer a very short reply. 1.08. What is the ratio of the Area (in %) of Germany in 1972 to that in 1977?
Your response must be concise. 1.01. What is the ratio of the Area (in %) of Egypt, Arab Rep. in 1972 to that in 1978?
Offer a terse response. 1.12. What is the ratio of the Area (in %) in Germany in 1972 to that in 1978?
Provide a short and direct response. 1.02. What is the ratio of the Area (in %) of Brunei Darussalam in 1973 to that in 1974?
Provide a short and direct response. 1. What is the ratio of the Area (in %) of Chad in 1973 to that in 1974?
Offer a very short reply. 1. What is the ratio of the Area (in %) of Egypt, Arab Rep. in 1973 to that in 1974?
Make the answer very short. 1. What is the ratio of the Area (in %) of Brunei Darussalam in 1973 to that in 1975?
Your answer should be very brief. 1. What is the ratio of the Area (in %) in Egypt, Arab Rep. in 1973 to that in 1975?
Provide a short and direct response. 1.01. What is the ratio of the Area (in %) of Germany in 1973 to that in 1975?
Your response must be concise. 1.01. What is the ratio of the Area (in %) of Brunei Darussalam in 1973 to that in 1976?
Offer a terse response. 1.06. What is the ratio of the Area (in %) in Chad in 1973 to that in 1976?
Provide a succinct answer. 1. What is the ratio of the Area (in %) of Egypt, Arab Rep. in 1973 to that in 1976?
Provide a short and direct response. 1.05. What is the ratio of the Area (in %) in Germany in 1973 to that in 1976?
Your answer should be very brief. 1.01. What is the ratio of the Area (in %) of Brunei Darussalam in 1973 to that in 1977?
Provide a succinct answer. 1.2. What is the ratio of the Area (in %) of Egypt, Arab Rep. in 1973 to that in 1977?
Provide a succinct answer. 1.08. What is the ratio of the Area (in %) in Germany in 1973 to that in 1977?
Keep it short and to the point. 1.01. What is the ratio of the Area (in %) in Brunei Darussalam in 1973 to that in 1978?
Provide a succinct answer. 1.2. What is the ratio of the Area (in %) of Chad in 1973 to that in 1978?
Keep it short and to the point. 0.99. What is the ratio of the Area (in %) of Egypt, Arab Rep. in 1973 to that in 1978?
Offer a very short reply. 1.12. What is the ratio of the Area (in %) in Germany in 1973 to that in 1978?
Your answer should be compact. 1.01. What is the ratio of the Area (in %) in Brunei Darussalam in 1974 to that in 1975?
Your answer should be compact. 1. What is the ratio of the Area (in %) of Chad in 1974 to that in 1975?
Your answer should be very brief. 1. What is the ratio of the Area (in %) in Egypt, Arab Rep. in 1974 to that in 1975?
Offer a very short reply. 1.01. What is the ratio of the Area (in %) in Brunei Darussalam in 1974 to that in 1976?
Make the answer very short. 1.06. What is the ratio of the Area (in %) in Chad in 1974 to that in 1976?
Provide a short and direct response. 1. What is the ratio of the Area (in %) in Egypt, Arab Rep. in 1974 to that in 1976?
Ensure brevity in your answer.  1.04. What is the ratio of the Area (in %) of Brunei Darussalam in 1974 to that in 1977?
Make the answer very short. 1.2. What is the ratio of the Area (in %) in Egypt, Arab Rep. in 1974 to that in 1977?
Keep it short and to the point. 1.08. What is the ratio of the Area (in %) of Egypt, Arab Rep. in 1974 to that in 1978?
Keep it short and to the point. 1.12. What is the ratio of the Area (in %) in Germany in 1974 to that in 1978?
Provide a short and direct response. 1.01. What is the ratio of the Area (in %) in Brunei Darussalam in 1975 to that in 1976?
Offer a very short reply. 1.06. What is the ratio of the Area (in %) of Egypt, Arab Rep. in 1975 to that in 1976?
Provide a short and direct response. 1.03. What is the ratio of the Area (in %) of Germany in 1975 to that in 1976?
Offer a terse response. 1. What is the ratio of the Area (in %) in Egypt, Arab Rep. in 1975 to that in 1977?
Provide a succinct answer. 1.07. What is the ratio of the Area (in %) in Egypt, Arab Rep. in 1975 to that in 1978?
Your answer should be compact. 1.11. What is the ratio of the Area (in %) in Germany in 1975 to that in 1978?
Offer a terse response. 1.01. What is the ratio of the Area (in %) of Brunei Darussalam in 1976 to that in 1977?
Your response must be concise. 1.13. What is the ratio of the Area (in %) in Egypt, Arab Rep. in 1976 to that in 1977?
Your response must be concise. 1.04. What is the ratio of the Area (in %) of Brunei Darussalam in 1976 to that in 1978?
Provide a succinct answer. 1.13. What is the ratio of the Area (in %) of Chad in 1976 to that in 1978?
Offer a very short reply. 1. What is the ratio of the Area (in %) of Egypt, Arab Rep. in 1976 to that in 1978?
Ensure brevity in your answer.  1.07. What is the ratio of the Area (in %) in Germany in 1976 to that in 1978?
Your answer should be compact. 1.01. What is the ratio of the Area (in %) of Brunei Darussalam in 1977 to that in 1978?
Keep it short and to the point. 1. What is the ratio of the Area (in %) in Chad in 1977 to that in 1978?
Your response must be concise. 1. What is the ratio of the Area (in %) of Egypt, Arab Rep. in 1977 to that in 1978?
Your answer should be very brief. 1.04. What is the difference between the highest and the second highest Area (in %) in Brunei Darussalam?
Make the answer very short. 0.19. What is the difference between the highest and the second highest Area (in %) of Chad?
Offer a very short reply. 0.04. What is the difference between the highest and the second highest Area (in %) in Germany?
Provide a short and direct response. 0.01. What is the difference between the highest and the lowest Area (in %) in Brunei Darussalam?
Make the answer very short. 0.76. What is the difference between the highest and the lowest Area (in %) in Chad?
Your answer should be very brief. 0.22. What is the difference between the highest and the lowest Area (in %) in Egypt, Arab Rep.?
Provide a short and direct response. 0.32. What is the difference between the highest and the lowest Area (in %) in Germany?
Give a very brief answer. 0.84. 